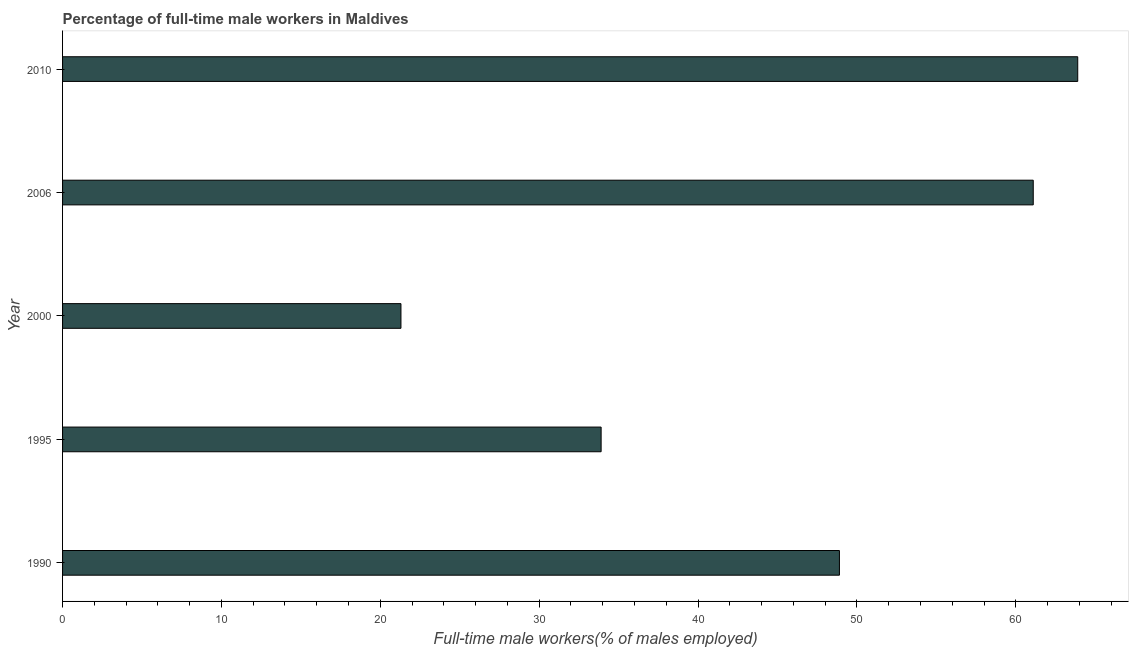Does the graph contain any zero values?
Provide a succinct answer. No. Does the graph contain grids?
Provide a short and direct response. No. What is the title of the graph?
Give a very brief answer. Percentage of full-time male workers in Maldives. What is the label or title of the X-axis?
Provide a succinct answer. Full-time male workers(% of males employed). What is the percentage of full-time male workers in 2006?
Offer a terse response. 61.1. Across all years, what is the maximum percentage of full-time male workers?
Your response must be concise. 63.9. Across all years, what is the minimum percentage of full-time male workers?
Provide a succinct answer. 21.3. In which year was the percentage of full-time male workers maximum?
Ensure brevity in your answer.  2010. In which year was the percentage of full-time male workers minimum?
Offer a very short reply. 2000. What is the sum of the percentage of full-time male workers?
Your response must be concise. 229.1. What is the difference between the percentage of full-time male workers in 2000 and 2006?
Give a very brief answer. -39.8. What is the average percentage of full-time male workers per year?
Your response must be concise. 45.82. What is the median percentage of full-time male workers?
Make the answer very short. 48.9. In how many years, is the percentage of full-time male workers greater than 48 %?
Your answer should be very brief. 3. What is the ratio of the percentage of full-time male workers in 1990 to that in 1995?
Provide a short and direct response. 1.44. Is the percentage of full-time male workers in 1990 less than that in 2006?
Your response must be concise. Yes. What is the difference between the highest and the second highest percentage of full-time male workers?
Keep it short and to the point. 2.8. What is the difference between the highest and the lowest percentage of full-time male workers?
Keep it short and to the point. 42.6. How many bars are there?
Ensure brevity in your answer.  5. Are all the bars in the graph horizontal?
Your answer should be compact. Yes. What is the Full-time male workers(% of males employed) of 1990?
Your answer should be compact. 48.9. What is the Full-time male workers(% of males employed) of 1995?
Offer a very short reply. 33.9. What is the Full-time male workers(% of males employed) in 2000?
Your answer should be very brief. 21.3. What is the Full-time male workers(% of males employed) of 2006?
Keep it short and to the point. 61.1. What is the Full-time male workers(% of males employed) in 2010?
Keep it short and to the point. 63.9. What is the difference between the Full-time male workers(% of males employed) in 1990 and 1995?
Give a very brief answer. 15. What is the difference between the Full-time male workers(% of males employed) in 1990 and 2000?
Make the answer very short. 27.6. What is the difference between the Full-time male workers(% of males employed) in 1995 and 2006?
Ensure brevity in your answer.  -27.2. What is the difference between the Full-time male workers(% of males employed) in 1995 and 2010?
Give a very brief answer. -30. What is the difference between the Full-time male workers(% of males employed) in 2000 and 2006?
Your answer should be compact. -39.8. What is the difference between the Full-time male workers(% of males employed) in 2000 and 2010?
Keep it short and to the point. -42.6. What is the difference between the Full-time male workers(% of males employed) in 2006 and 2010?
Offer a very short reply. -2.8. What is the ratio of the Full-time male workers(% of males employed) in 1990 to that in 1995?
Keep it short and to the point. 1.44. What is the ratio of the Full-time male workers(% of males employed) in 1990 to that in 2000?
Your answer should be very brief. 2.3. What is the ratio of the Full-time male workers(% of males employed) in 1990 to that in 2006?
Provide a succinct answer. 0.8. What is the ratio of the Full-time male workers(% of males employed) in 1990 to that in 2010?
Keep it short and to the point. 0.77. What is the ratio of the Full-time male workers(% of males employed) in 1995 to that in 2000?
Give a very brief answer. 1.59. What is the ratio of the Full-time male workers(% of males employed) in 1995 to that in 2006?
Offer a terse response. 0.56. What is the ratio of the Full-time male workers(% of males employed) in 1995 to that in 2010?
Ensure brevity in your answer.  0.53. What is the ratio of the Full-time male workers(% of males employed) in 2000 to that in 2006?
Keep it short and to the point. 0.35. What is the ratio of the Full-time male workers(% of males employed) in 2000 to that in 2010?
Ensure brevity in your answer.  0.33. What is the ratio of the Full-time male workers(% of males employed) in 2006 to that in 2010?
Your answer should be very brief. 0.96. 